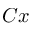<formula> <loc_0><loc_0><loc_500><loc_500>C x</formula> 